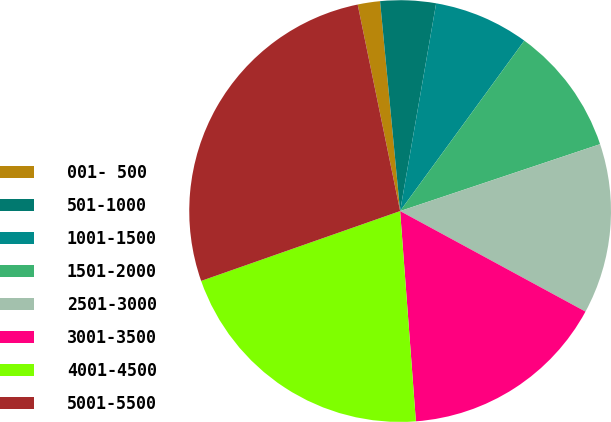Convert chart. <chart><loc_0><loc_0><loc_500><loc_500><pie_chart><fcel>001- 500<fcel>501-1000<fcel>1001-1500<fcel>1501-2000<fcel>2501-3000<fcel>3001-3500<fcel>4001-4500<fcel>5001-5500<nl><fcel>1.71%<fcel>4.25%<fcel>7.29%<fcel>9.84%<fcel>13.05%<fcel>15.9%<fcel>20.82%<fcel>27.15%<nl></chart> 